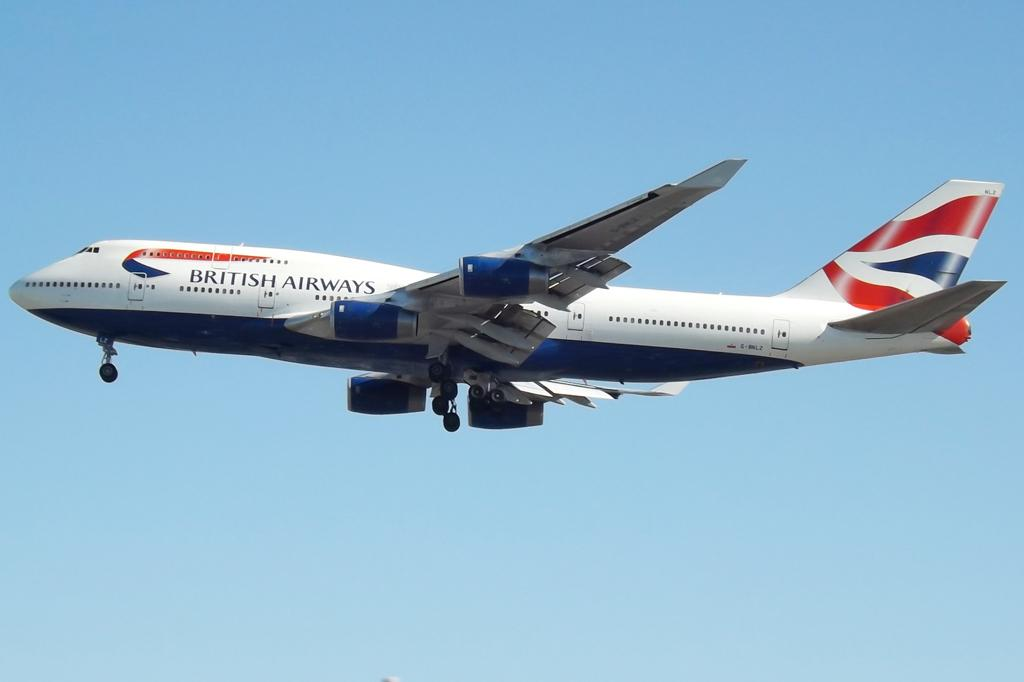<image>
Offer a succinct explanation of the picture presented. A white red and blue airplan that says British Airways on the side. 